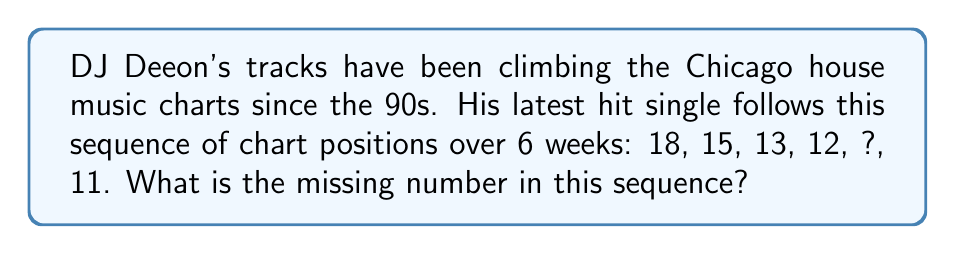Can you answer this question? Let's analyze this sequence step-by-step:

1) First, we need to identify the pattern in the given sequence.

2) The differences between consecutive terms are:
   18 to 15: -3
   15 to 13: -2
   13 to 12: -1
   12 to ?: unknown
   ? to 11: unknown

3) We can see that the difference is decreasing by 1 each time:
   -3, -2, -1, ...

4) Following this pattern, the next difference should be 0.

5) So, from 12 to the missing number, the difference should be 0.

6) Therefore, the missing number is the same as the previous number: 12.

7) We can verify this by checking the difference to the next number:
   12 to 11 is indeed -1, which follows the pattern.

Thus, the missing number in the sequence is 12.
Answer: 12 